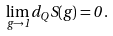<formula> <loc_0><loc_0><loc_500><loc_500>\lim _ { g \to 1 } d _ { Q } S ( g ) = 0 \, .</formula> 